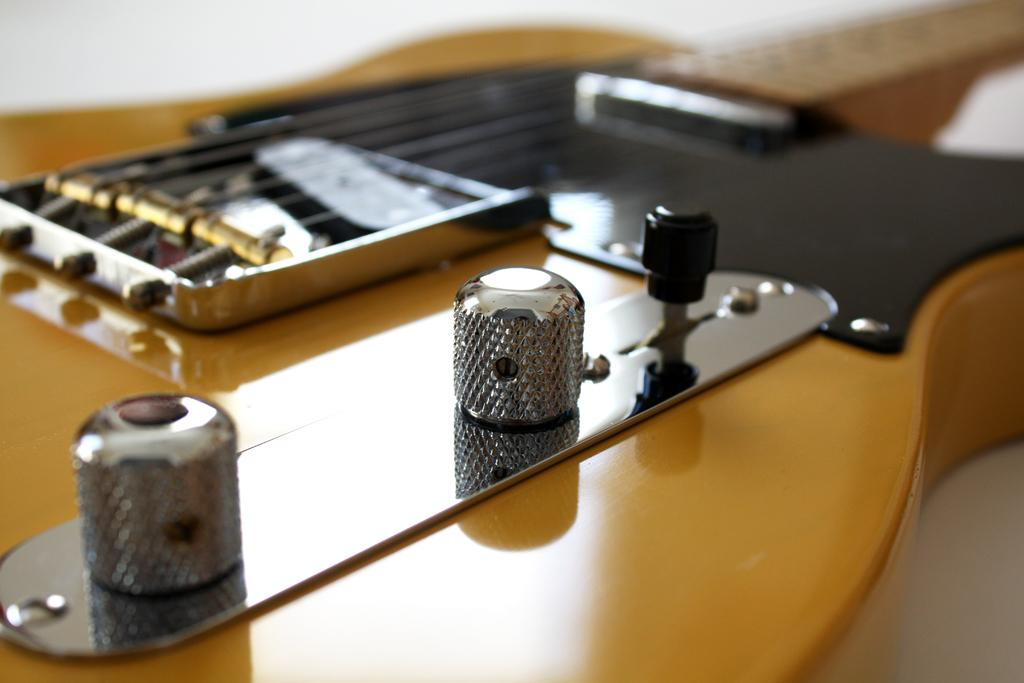What type of musical instrument is in the image? There is a brown color guitar in the image. What are the guitar's features? The guitar has screws and strings. How many screws are visible on the left side of the guitar? There are three screws on the left side of the guitar where the strings are attached. What type of stocking is hanging from the guitar in the image? There is no stocking present in the image; it only features a brown color guitar with screws and strings. 